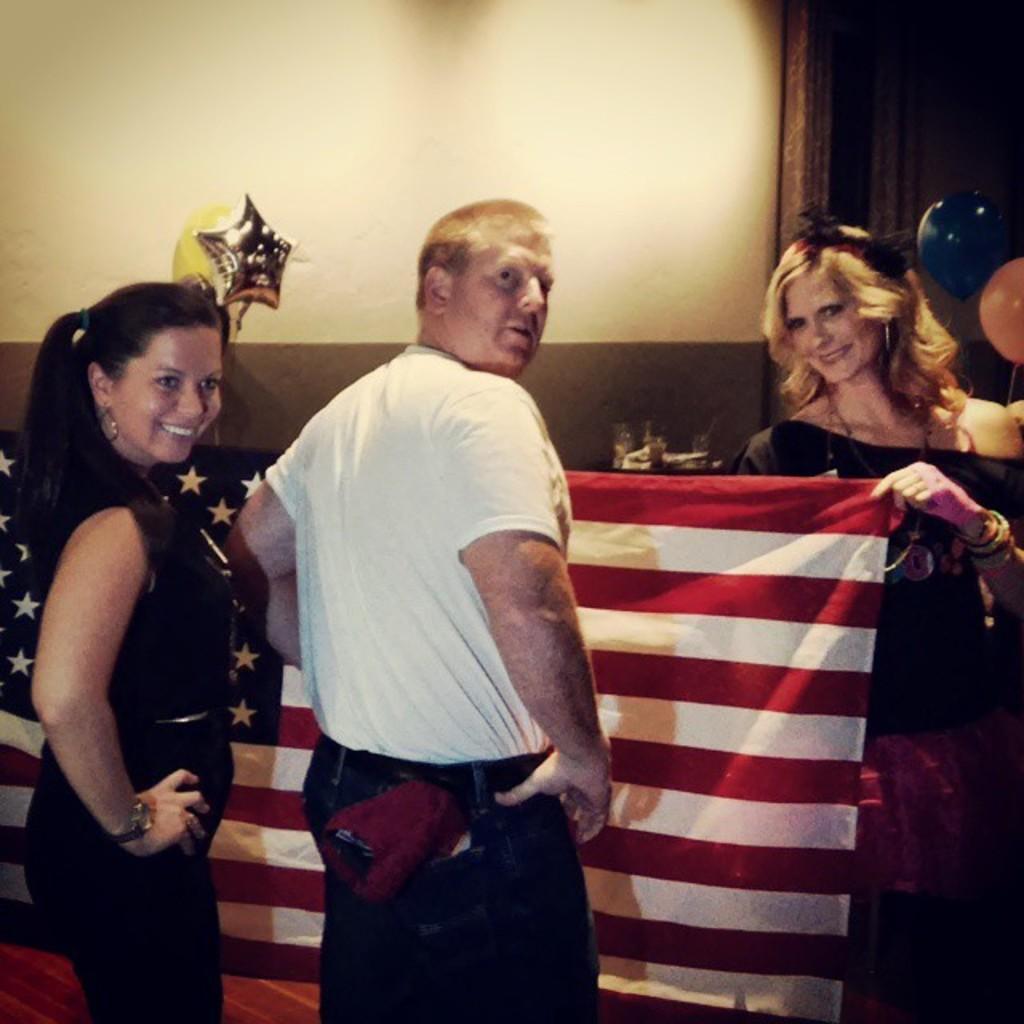In one or two sentences, can you explain what this image depicts? In this picture we can see three persons on the right side woman is holding a flag in her hand and the center person wearing white color T- Shirt and at left side we can see a woman wearing a watch with a beautiful smile and at the background we can see a wall and two balloons blue and orange in color. 